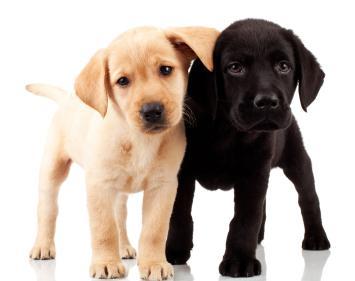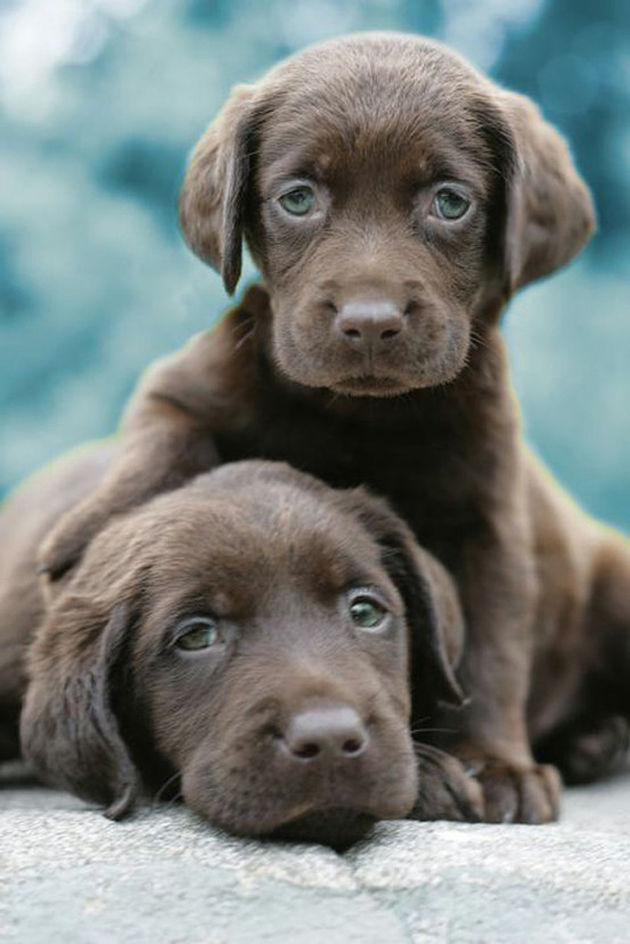The first image is the image on the left, the second image is the image on the right. Given the left and right images, does the statement "The left image features one golden and one black colored Labrador while the right image contains two chocolate or black lab puppies." hold true? Answer yes or no. Yes. 